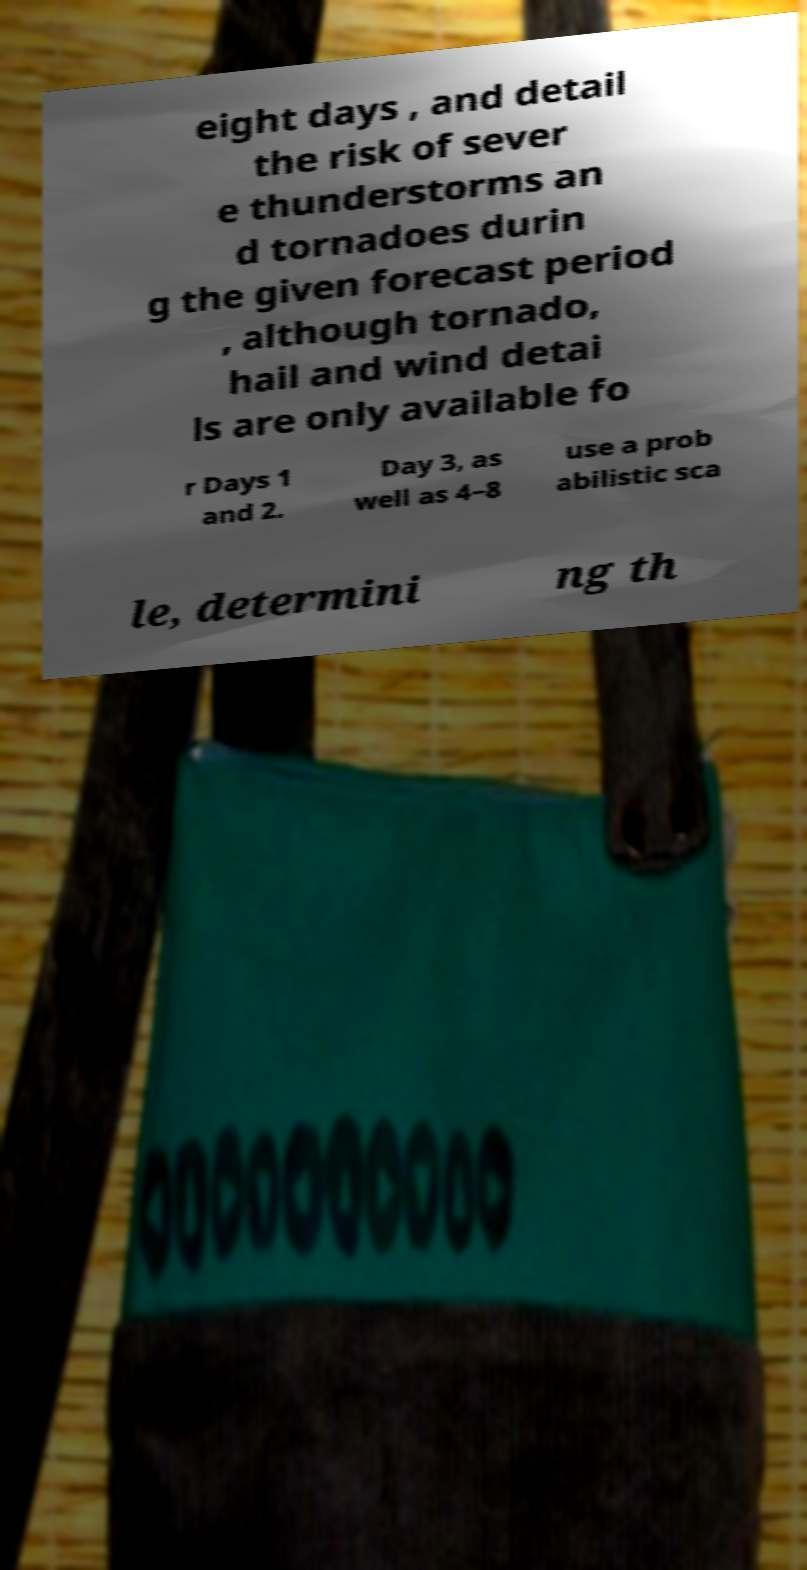Could you extract and type out the text from this image? eight days , and detail the risk of sever e thunderstorms an d tornadoes durin g the given forecast period , although tornado, hail and wind detai ls are only available fo r Days 1 and 2. Day 3, as well as 4–8 use a prob abilistic sca le, determini ng th 